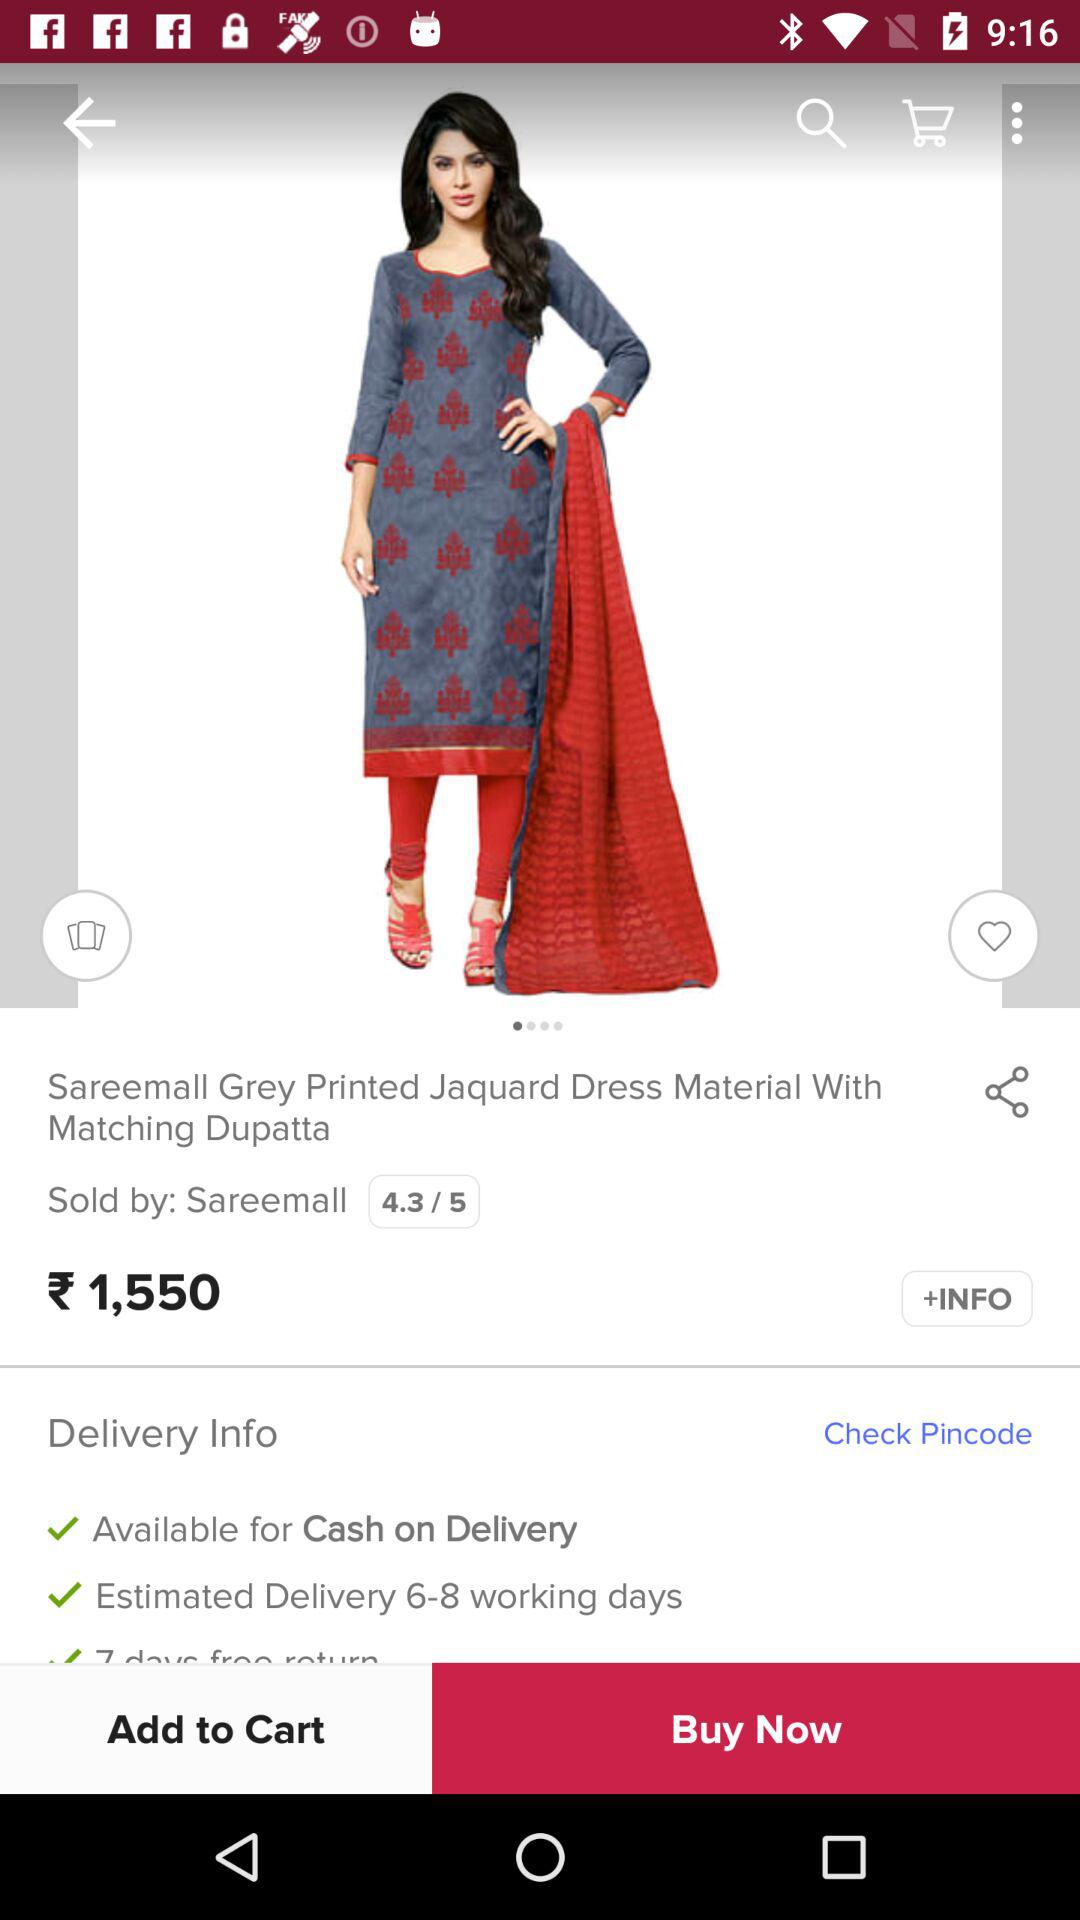What is the delivery time of the product?
Answer the question using a single word or phrase. 6-8 working days 